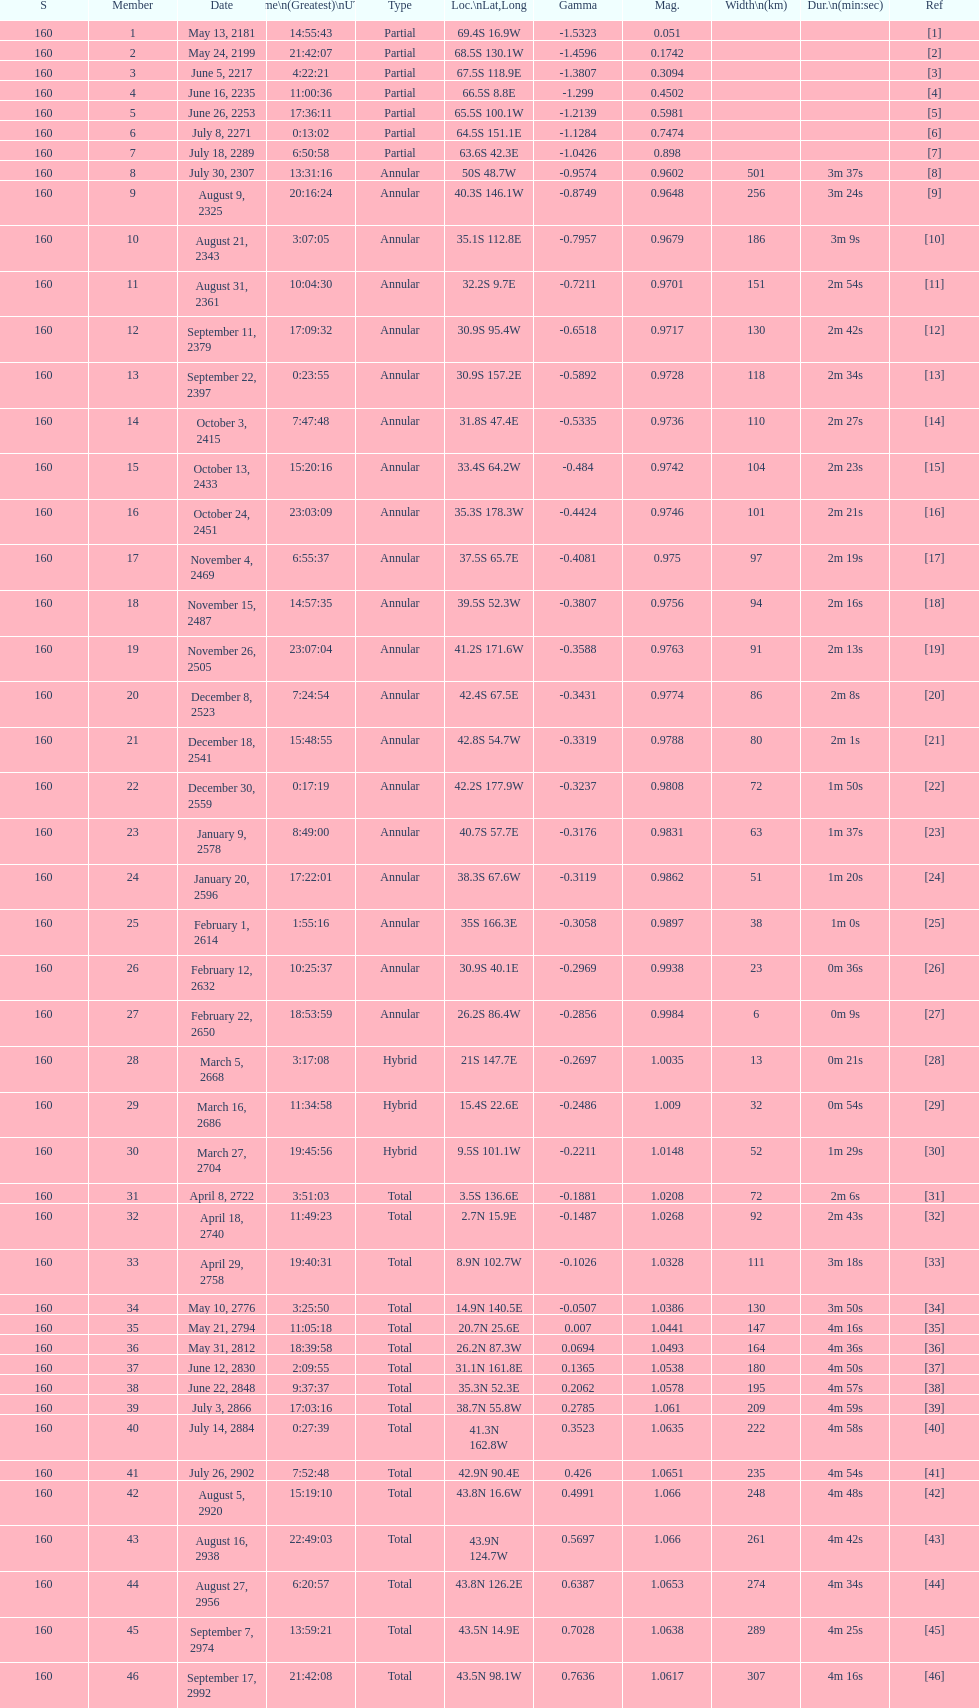Name one that has the same latitude as member number 12. 13. 